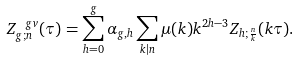<formula> <loc_0><loc_0><loc_500><loc_500>Z ^ { \ g v } _ { g ; n } ( \tau ) = \sum _ { h = 0 } ^ { g } \alpha _ { g , h } \sum _ { k | n } \mu ( k ) k ^ { 2 h - 3 } Z _ { h ; \frac { n } { k } } ( k \tau ) .</formula> 